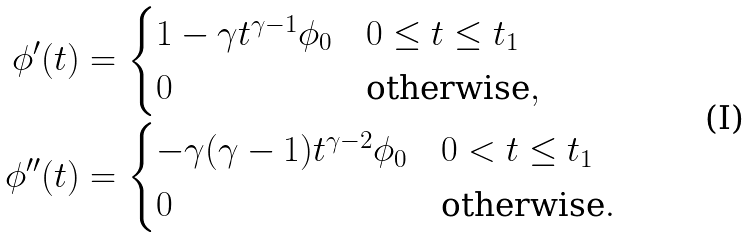<formula> <loc_0><loc_0><loc_500><loc_500>\phi ^ { \prime } ( t ) & = \begin{cases} 1 - \gamma t ^ { \gamma - 1 } \phi _ { 0 } & 0 \leq t \leq t _ { 1 } \\ 0 & \text {otherwise} , \end{cases} \\ \phi ^ { \prime \prime } ( t ) & = \begin{cases} - \gamma ( \gamma - 1 ) t ^ { \gamma - 2 } \phi _ { 0 } & 0 < t \leq t _ { 1 } \\ 0 & \text {otherwise} . \end{cases}</formula> 